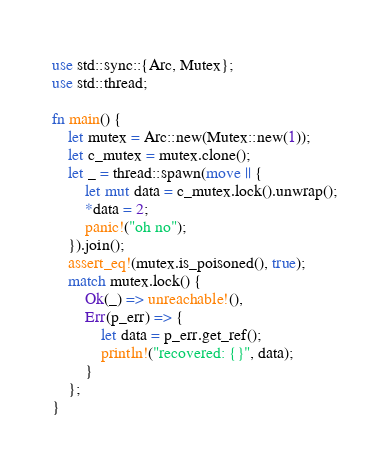<code> <loc_0><loc_0><loc_500><loc_500><_Rust_>use std::sync::{Arc, Mutex};
use std::thread;

fn main() {
    let mutex = Arc::new(Mutex::new(1));
    let c_mutex = mutex.clone();
    let _ = thread::spawn(move || {
        let mut data = c_mutex.lock().unwrap();
        *data = 2;
        panic!("oh no");
    }).join();
    assert_eq!(mutex.is_poisoned(), true);
    match mutex.lock() {
        Ok(_) => unreachable!(),
        Err(p_err) => {
            let data = p_err.get_ref();
            println!("recovered: {}", data);
        }
    };
}
</code> 